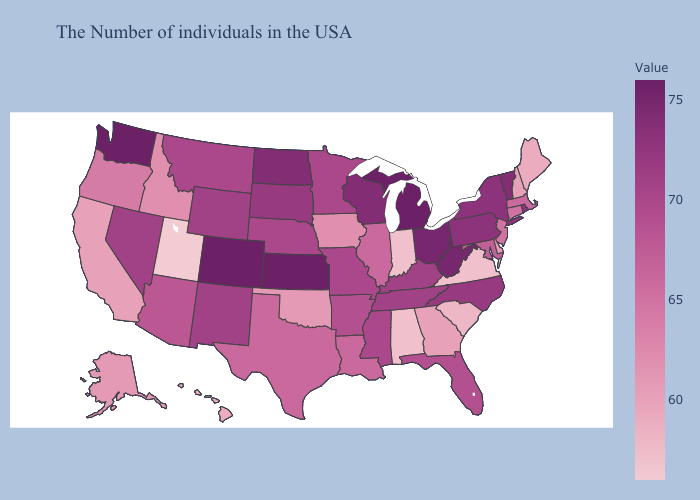Does Virginia have the lowest value in the USA?
Keep it brief. No. Among the states that border Montana , which have the highest value?
Be succinct. North Dakota. Does Vermont have the lowest value in the Northeast?
Give a very brief answer. No. Does Alaska have a higher value than Illinois?
Quick response, please. No. 